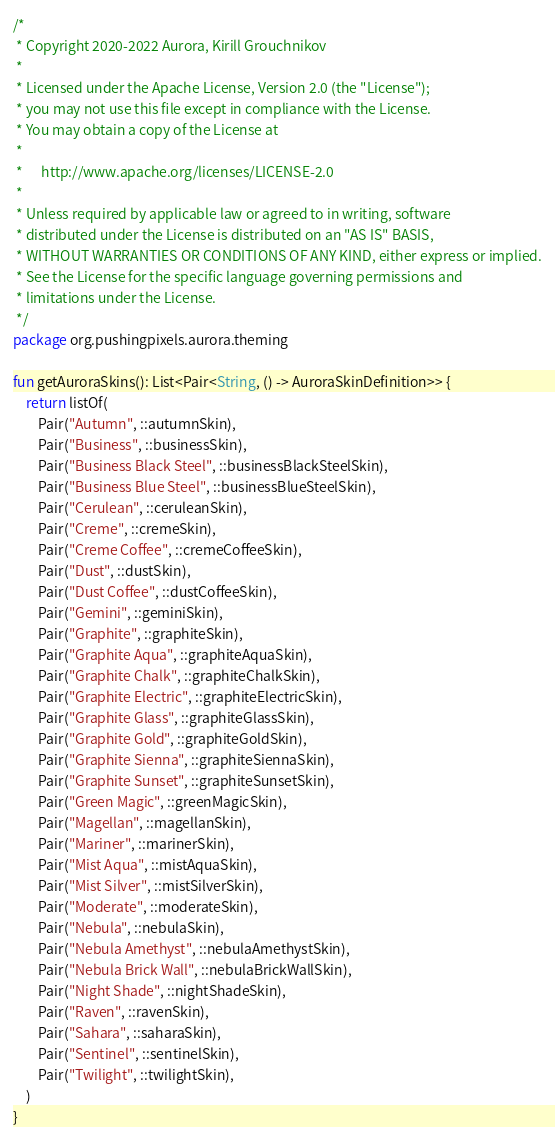<code> <loc_0><loc_0><loc_500><loc_500><_Kotlin_>/*
 * Copyright 2020-2022 Aurora, Kirill Grouchnikov
 *
 * Licensed under the Apache License, Version 2.0 (the "License");
 * you may not use this file except in compliance with the License.
 * You may obtain a copy of the License at
 *
 *      http://www.apache.org/licenses/LICENSE-2.0
 *
 * Unless required by applicable law or agreed to in writing, software
 * distributed under the License is distributed on an "AS IS" BASIS,
 * WITHOUT WARRANTIES OR CONDITIONS OF ANY KIND, either express or implied.
 * See the License for the specific language governing permissions and
 * limitations under the License.
 */
package org.pushingpixels.aurora.theming

fun getAuroraSkins(): List<Pair<String, () -> AuroraSkinDefinition>> {
    return listOf(
        Pair("Autumn", ::autumnSkin),
        Pair("Business", ::businessSkin),
        Pair("Business Black Steel", ::businessBlackSteelSkin),
        Pair("Business Blue Steel", ::businessBlueSteelSkin),
        Pair("Cerulean", ::ceruleanSkin),
        Pair("Creme", ::cremeSkin),
        Pair("Creme Coffee", ::cremeCoffeeSkin),
        Pair("Dust", ::dustSkin),
        Pair("Dust Coffee", ::dustCoffeeSkin),
        Pair("Gemini", ::geminiSkin),
        Pair("Graphite", ::graphiteSkin),
        Pair("Graphite Aqua", ::graphiteAquaSkin),
        Pair("Graphite Chalk", ::graphiteChalkSkin),
        Pair("Graphite Electric", ::graphiteElectricSkin),
        Pair("Graphite Glass", ::graphiteGlassSkin),
        Pair("Graphite Gold", ::graphiteGoldSkin),
        Pair("Graphite Sienna", ::graphiteSiennaSkin),
        Pair("Graphite Sunset", ::graphiteSunsetSkin),
        Pair("Green Magic", ::greenMagicSkin),
        Pair("Magellan", ::magellanSkin),
        Pair("Mariner", ::marinerSkin),
        Pair("Mist Aqua", ::mistAquaSkin),
        Pair("Mist Silver", ::mistSilverSkin),
        Pair("Moderate", ::moderateSkin),
        Pair("Nebula", ::nebulaSkin),
        Pair("Nebula Amethyst", ::nebulaAmethystSkin),
        Pair("Nebula Brick Wall", ::nebulaBrickWallSkin),
        Pair("Night Shade", ::nightShadeSkin),
        Pair("Raven", ::ravenSkin),
        Pair("Sahara", ::saharaSkin),
        Pair("Sentinel", ::sentinelSkin),
        Pair("Twilight", ::twilightSkin),
    )
}
</code> 